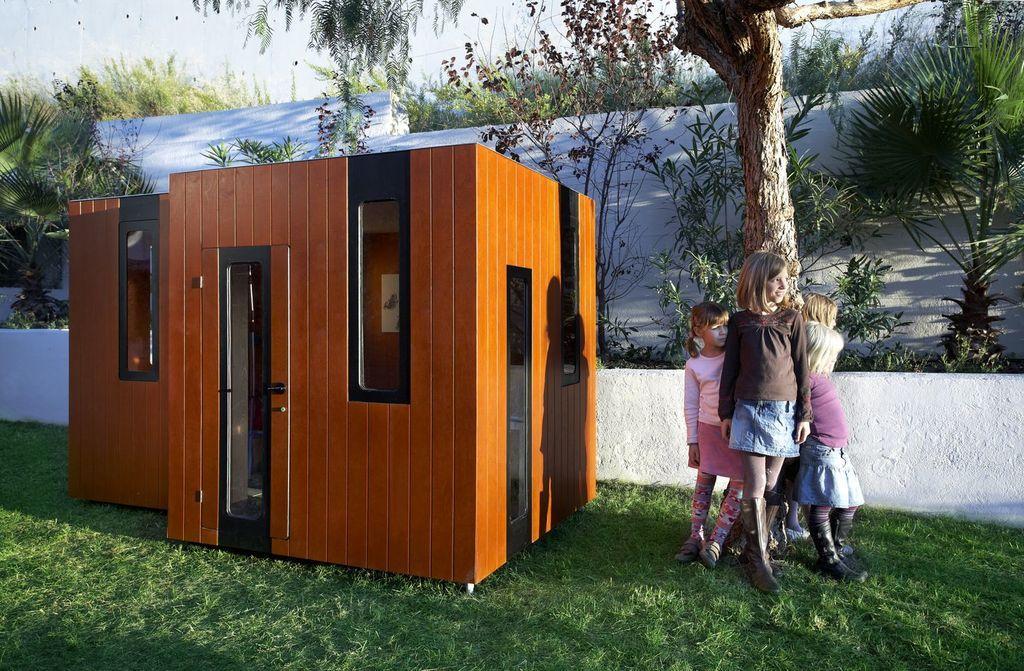Can you describe this image briefly? In this image I can see a wooden container and I can see a there are four children standing in front of the tree on the grass ,at the top I can see the wall ,in front of the wall I can see plants and trees and at the top I can see the sky. 